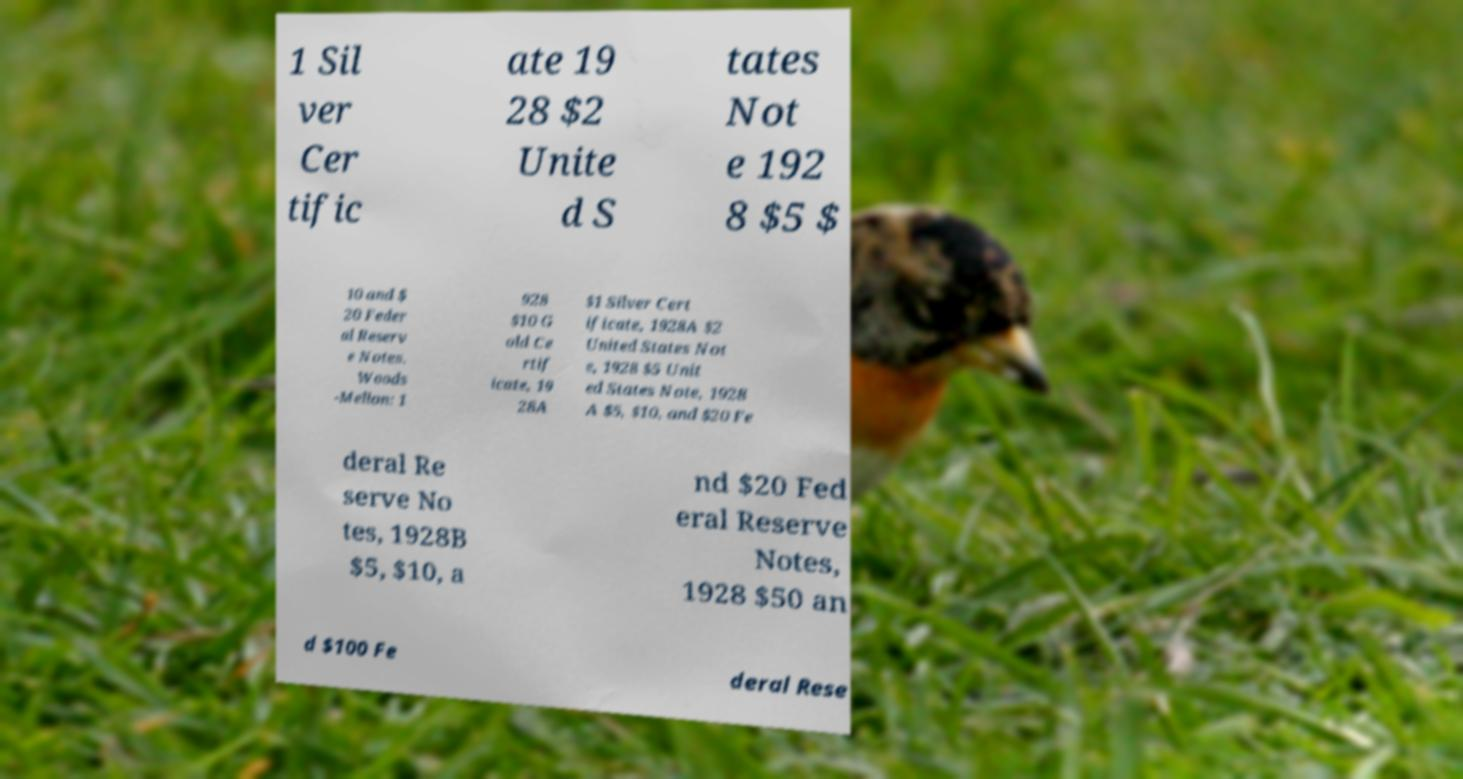Can you accurately transcribe the text from the provided image for me? 1 Sil ver Cer tific ate 19 28 $2 Unite d S tates Not e 192 8 $5 $ 10 and $ 20 Feder al Reserv e Notes. Woods -Mellon: 1 928 $10 G old Ce rtif icate, 19 28A $1 Silver Cert ificate, 1928A $2 United States Not e, 1928 $5 Unit ed States Note, 1928 A $5, $10, and $20 Fe deral Re serve No tes, 1928B $5, $10, a nd $20 Fed eral Reserve Notes, 1928 $50 an d $100 Fe deral Rese 